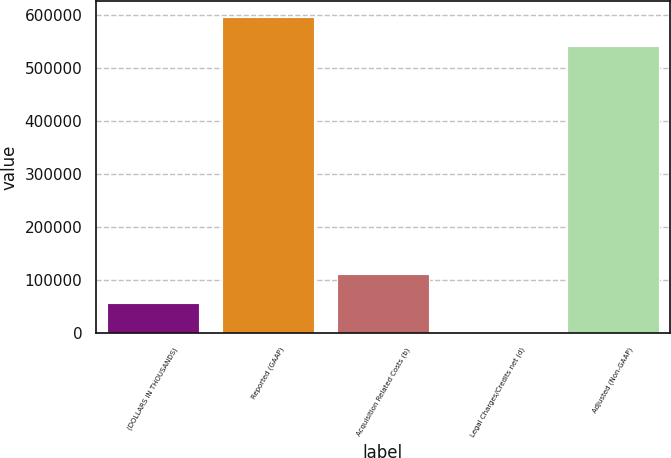Convert chart. <chart><loc_0><loc_0><loc_500><loc_500><bar_chart><fcel>(DOLLARS IN THOUSANDS)<fcel>Reported (GAAP)<fcel>Acquisition Related Costs (b)<fcel>Legal Charges/Credits net (d)<fcel>Adjusted (Non-GAAP)<nl><fcel>56631.1<fcel>596942<fcel>112262<fcel>1000<fcel>541311<nl></chart> 